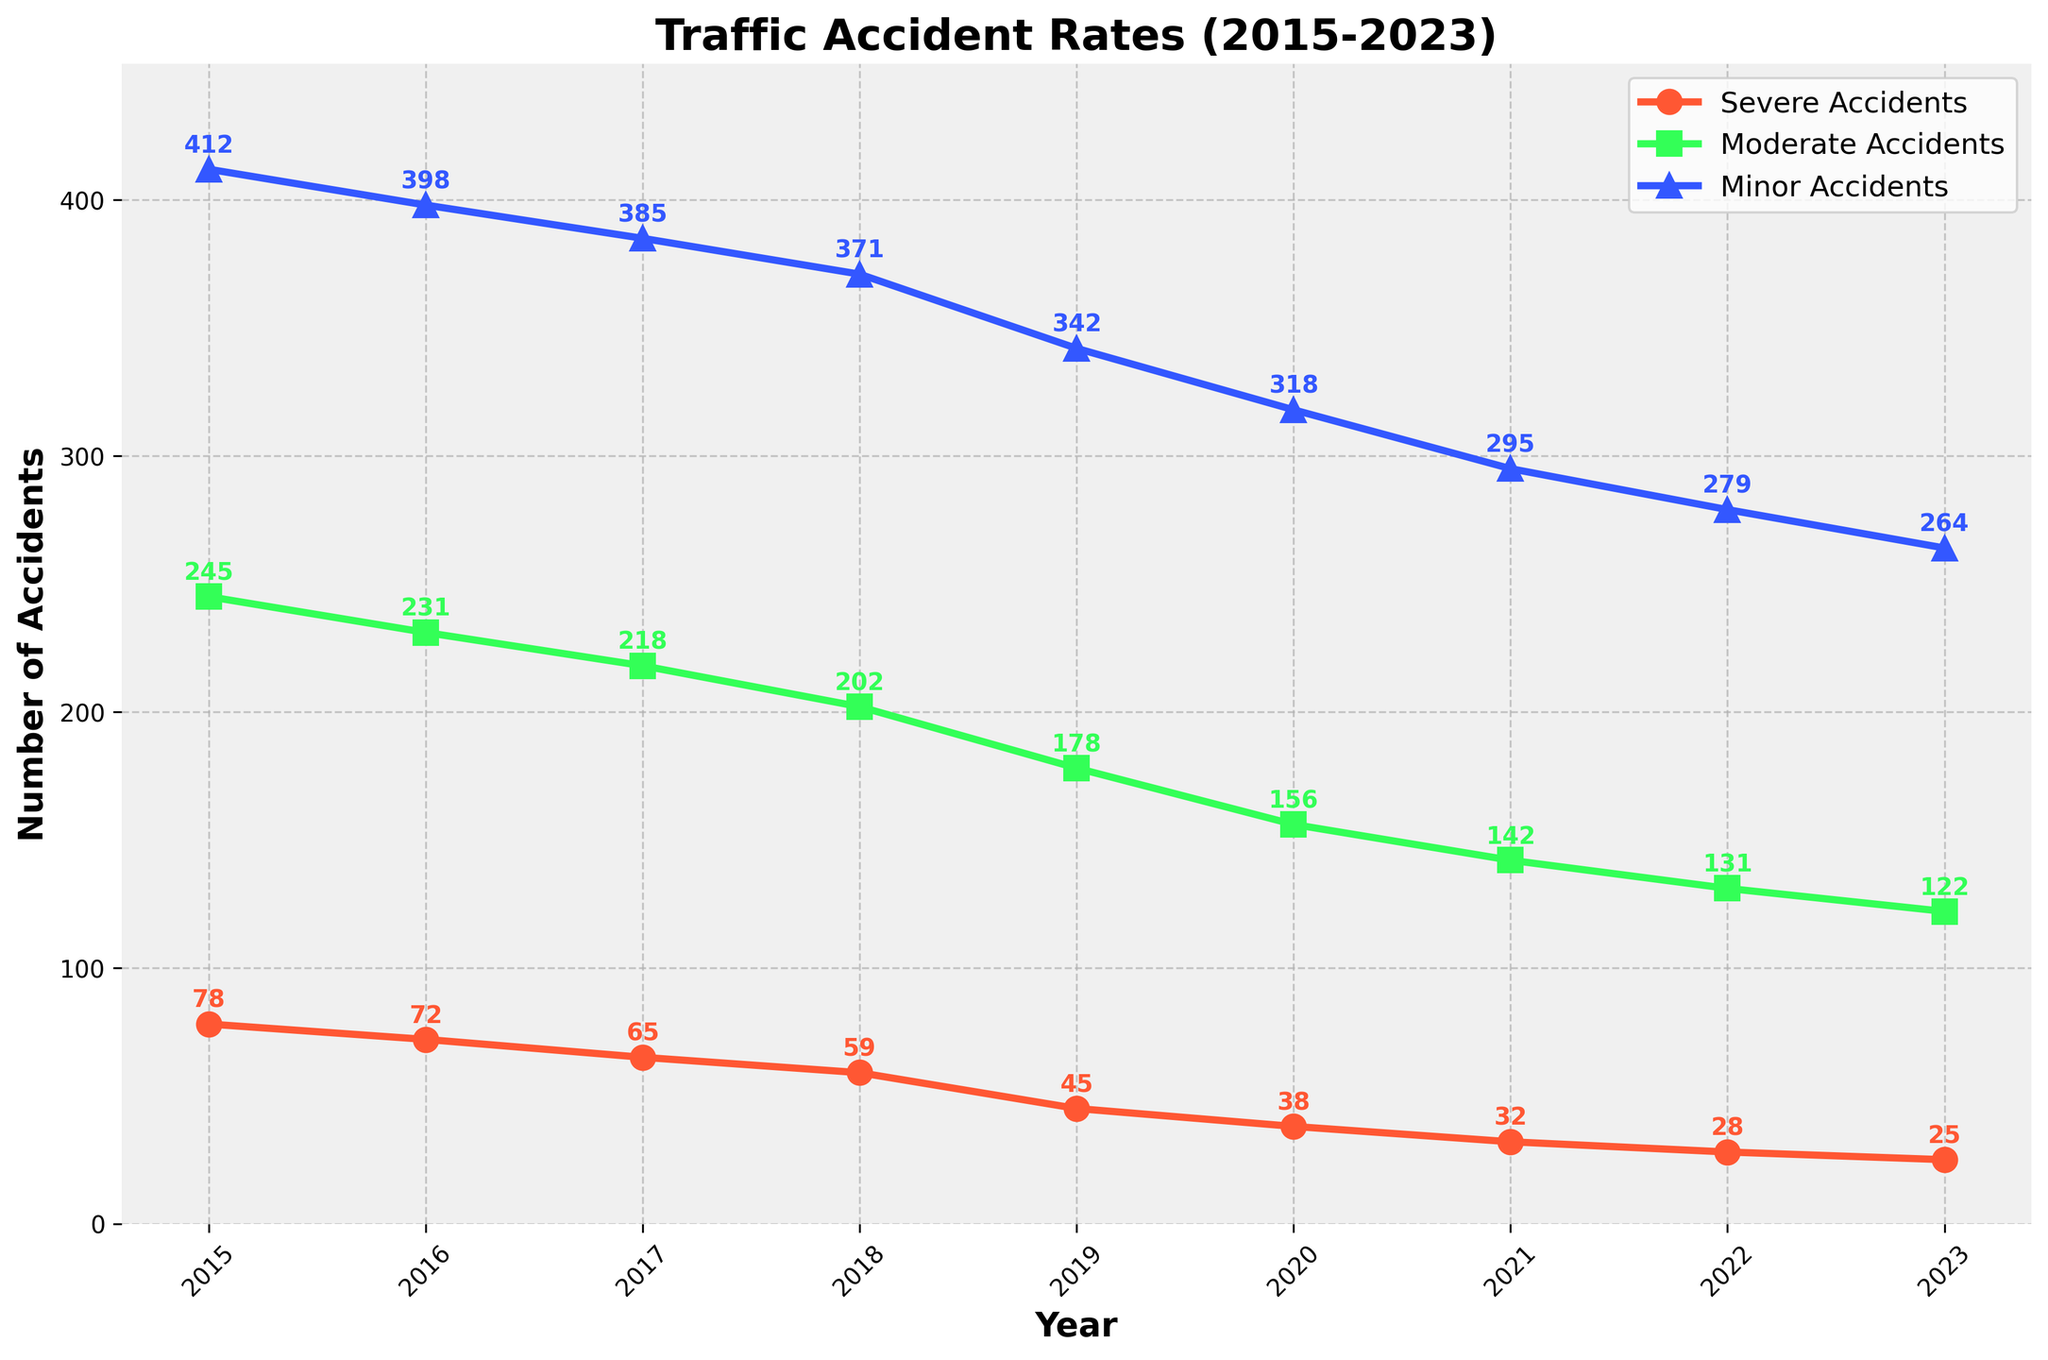What's the overall trend in severe accidents from 2015 to 2023? The severe accidents graph shows a declining trend from 78 accidents in 2015 to 25 accidents in 2023. The line representing severe accidents continuously drops each year.
Answer: Declining trend By how much did moderate accidents decrease from 2015 to 2023? In 2015, there were 245 moderate accidents. By 2023, this number had decreased to 122. The difference is 245 - 122 = 123.
Answer: 123 How many total minor accidents were recorded in the years 2020 and 2021 combined? In 2020, there were 318 minor accidents, and in 2021, there were 295. Summing these gives 318 + 295 = 613.
Answer: 613 Which year showed the largest year-over-year decrease in severe accidents? From 2018 to 2019, severe accidents decreased from 59 to 45, making a decrease of 14. For other years, the decreases are less than 14.
Answer: 2018 to 2019 What is the color of the line representing moderate accidents, and what shape marker is used for it? The line representing moderate accidents is green and uses square-shaped markers.
Answer: Green, square Which category had the highest number of accidents in 2022? In 2022, the minor accidents were the highest at 279, versus 131 moderate accidents and 28 severe accidents.
Answer: Minor accidents Calculate the percentage decrease in minor accidents from 2015 to 2023. In 2015, there were 412 minor accidents. By 2023, this decreased to 264. The percentage decrease is ((412 - 264) / 412) * 100 ≈ 35.92%.
Answer: 35.92% Which year first shows a decrease to below 50 severe accidents? Severe accidents dropped below 50 in the year 2019, where the number recorded was 45.
Answer: 2019 Compare the number of severe accidents in 2016 and 2017. Which year had more severe accidents and by how much? In 2016, there were 72 severe accidents, while in 2017 there were 65. Therefore, 2016 had 72 - 65 = 7 more severe accidents than 2017.
Answer: 2016, by 7 